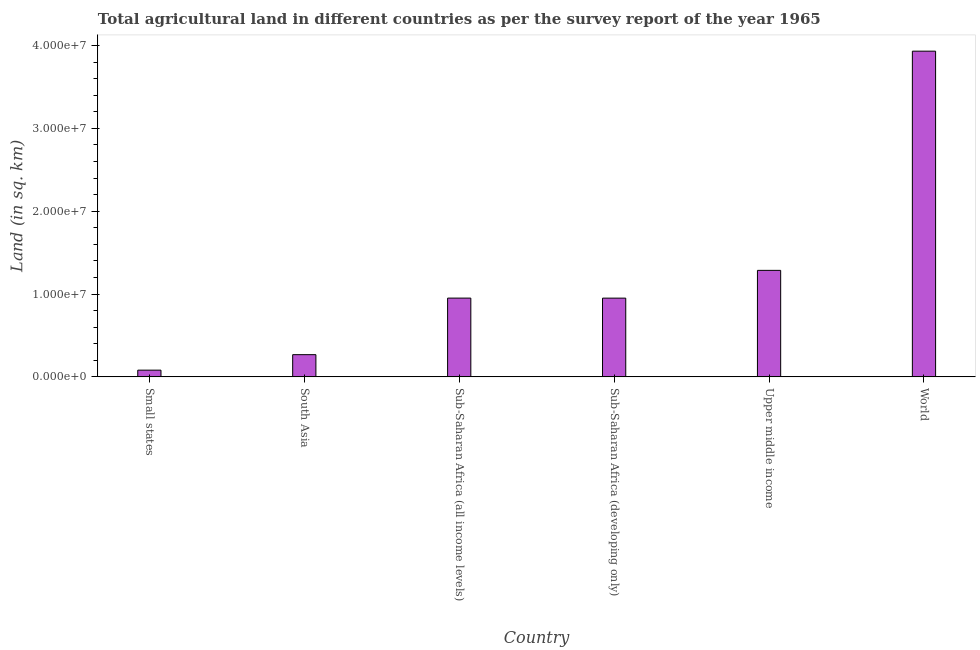Does the graph contain grids?
Your answer should be compact. No. What is the title of the graph?
Make the answer very short. Total agricultural land in different countries as per the survey report of the year 1965. What is the label or title of the X-axis?
Offer a very short reply. Country. What is the label or title of the Y-axis?
Your response must be concise. Land (in sq. km). What is the agricultural land in Small states?
Your response must be concise. 8.11e+05. Across all countries, what is the maximum agricultural land?
Keep it short and to the point. 3.93e+07. Across all countries, what is the minimum agricultural land?
Provide a short and direct response. 8.11e+05. In which country was the agricultural land minimum?
Offer a very short reply. Small states. What is the sum of the agricultural land?
Your response must be concise. 7.47e+07. What is the difference between the agricultural land in Sub-Saharan Africa (all income levels) and World?
Make the answer very short. -2.98e+07. What is the average agricultural land per country?
Provide a short and direct response. 1.24e+07. What is the median agricultural land?
Keep it short and to the point. 9.51e+06. What is the ratio of the agricultural land in Small states to that in Sub-Saharan Africa (all income levels)?
Make the answer very short. 0.09. Is the difference between the agricultural land in Sub-Saharan Africa (developing only) and World greater than the difference between any two countries?
Offer a very short reply. No. What is the difference between the highest and the second highest agricultural land?
Offer a very short reply. 2.65e+07. What is the difference between the highest and the lowest agricultural land?
Your answer should be compact. 3.85e+07. How many bars are there?
Your response must be concise. 6. Are all the bars in the graph horizontal?
Offer a very short reply. No. How many countries are there in the graph?
Give a very brief answer. 6. What is the difference between two consecutive major ticks on the Y-axis?
Provide a succinct answer. 1.00e+07. Are the values on the major ticks of Y-axis written in scientific E-notation?
Provide a short and direct response. Yes. What is the Land (in sq. km) in Small states?
Your response must be concise. 8.11e+05. What is the Land (in sq. km) in South Asia?
Ensure brevity in your answer.  2.68e+06. What is the Land (in sq. km) of Sub-Saharan Africa (all income levels)?
Make the answer very short. 9.51e+06. What is the Land (in sq. km) of Sub-Saharan Africa (developing only)?
Your response must be concise. 9.50e+06. What is the Land (in sq. km) in Upper middle income?
Your answer should be compact. 1.29e+07. What is the Land (in sq. km) of World?
Offer a very short reply. 3.93e+07. What is the difference between the Land (in sq. km) in Small states and South Asia?
Give a very brief answer. -1.87e+06. What is the difference between the Land (in sq. km) in Small states and Sub-Saharan Africa (all income levels)?
Your answer should be very brief. -8.70e+06. What is the difference between the Land (in sq. km) in Small states and Sub-Saharan Africa (developing only)?
Your answer should be compact. -8.69e+06. What is the difference between the Land (in sq. km) in Small states and Upper middle income?
Your answer should be very brief. -1.20e+07. What is the difference between the Land (in sq. km) in Small states and World?
Provide a short and direct response. -3.85e+07. What is the difference between the Land (in sq. km) in South Asia and Sub-Saharan Africa (all income levels)?
Provide a succinct answer. -6.83e+06. What is the difference between the Land (in sq. km) in South Asia and Sub-Saharan Africa (developing only)?
Offer a very short reply. -6.82e+06. What is the difference between the Land (in sq. km) in South Asia and Upper middle income?
Make the answer very short. -1.02e+07. What is the difference between the Land (in sq. km) in South Asia and World?
Your answer should be compact. -3.66e+07. What is the difference between the Land (in sq. km) in Sub-Saharan Africa (all income levels) and Sub-Saharan Africa (developing only)?
Make the answer very short. 3300. What is the difference between the Land (in sq. km) in Sub-Saharan Africa (all income levels) and Upper middle income?
Your answer should be very brief. -3.35e+06. What is the difference between the Land (in sq. km) in Sub-Saharan Africa (all income levels) and World?
Provide a short and direct response. -2.98e+07. What is the difference between the Land (in sq. km) in Sub-Saharan Africa (developing only) and Upper middle income?
Make the answer very short. -3.35e+06. What is the difference between the Land (in sq. km) in Sub-Saharan Africa (developing only) and World?
Your answer should be compact. -2.98e+07. What is the difference between the Land (in sq. km) in Upper middle income and World?
Your response must be concise. -2.65e+07. What is the ratio of the Land (in sq. km) in Small states to that in South Asia?
Provide a short and direct response. 0.3. What is the ratio of the Land (in sq. km) in Small states to that in Sub-Saharan Africa (all income levels)?
Provide a short and direct response. 0.09. What is the ratio of the Land (in sq. km) in Small states to that in Sub-Saharan Africa (developing only)?
Give a very brief answer. 0.09. What is the ratio of the Land (in sq. km) in Small states to that in Upper middle income?
Offer a very short reply. 0.06. What is the ratio of the Land (in sq. km) in Small states to that in World?
Provide a succinct answer. 0.02. What is the ratio of the Land (in sq. km) in South Asia to that in Sub-Saharan Africa (all income levels)?
Give a very brief answer. 0.28. What is the ratio of the Land (in sq. km) in South Asia to that in Sub-Saharan Africa (developing only)?
Keep it short and to the point. 0.28. What is the ratio of the Land (in sq. km) in South Asia to that in Upper middle income?
Provide a short and direct response. 0.21. What is the ratio of the Land (in sq. km) in South Asia to that in World?
Your answer should be compact. 0.07. What is the ratio of the Land (in sq. km) in Sub-Saharan Africa (all income levels) to that in Sub-Saharan Africa (developing only)?
Your answer should be very brief. 1. What is the ratio of the Land (in sq. km) in Sub-Saharan Africa (all income levels) to that in Upper middle income?
Provide a succinct answer. 0.74. What is the ratio of the Land (in sq. km) in Sub-Saharan Africa (all income levels) to that in World?
Provide a short and direct response. 0.24. What is the ratio of the Land (in sq. km) in Sub-Saharan Africa (developing only) to that in Upper middle income?
Make the answer very short. 0.74. What is the ratio of the Land (in sq. km) in Sub-Saharan Africa (developing only) to that in World?
Your answer should be very brief. 0.24. What is the ratio of the Land (in sq. km) in Upper middle income to that in World?
Offer a terse response. 0.33. 